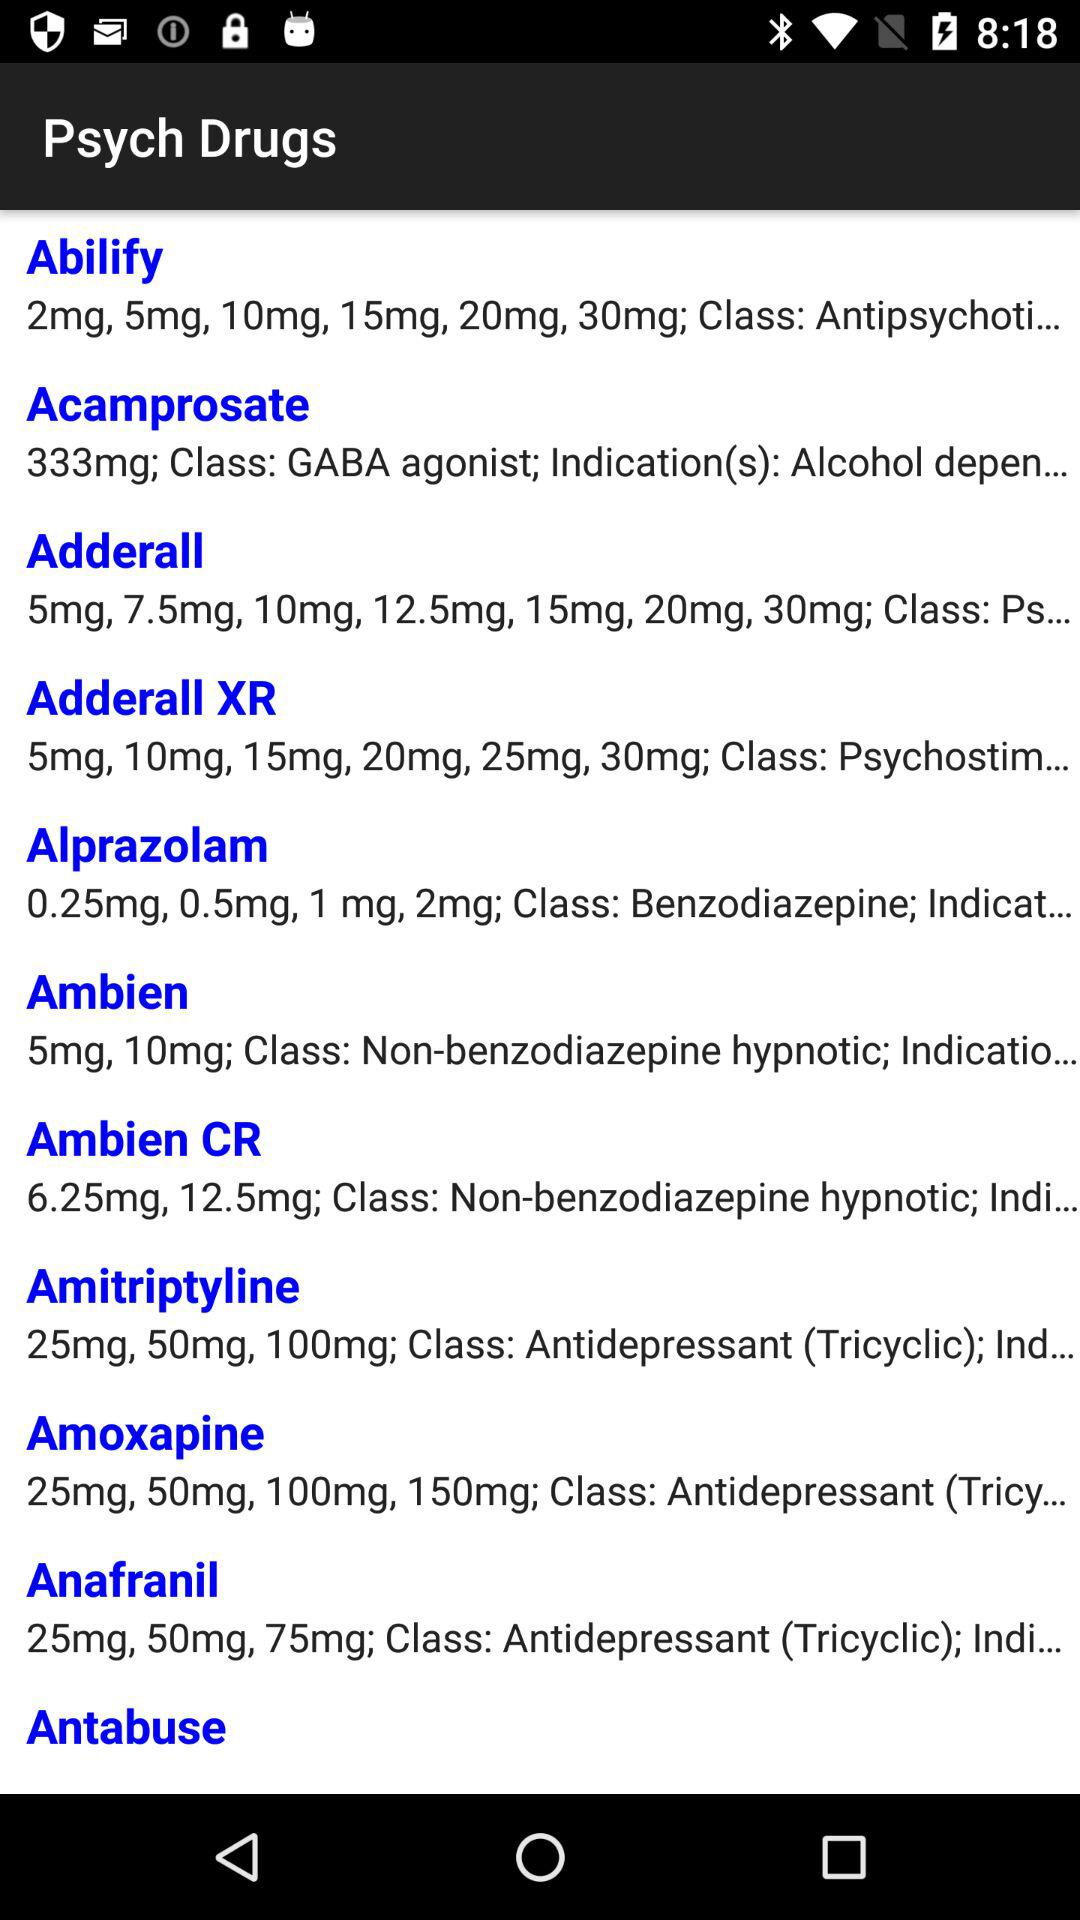What class of medications does Amitriptyline belong to? The class is "Antidepressant (Tricyclic)". 